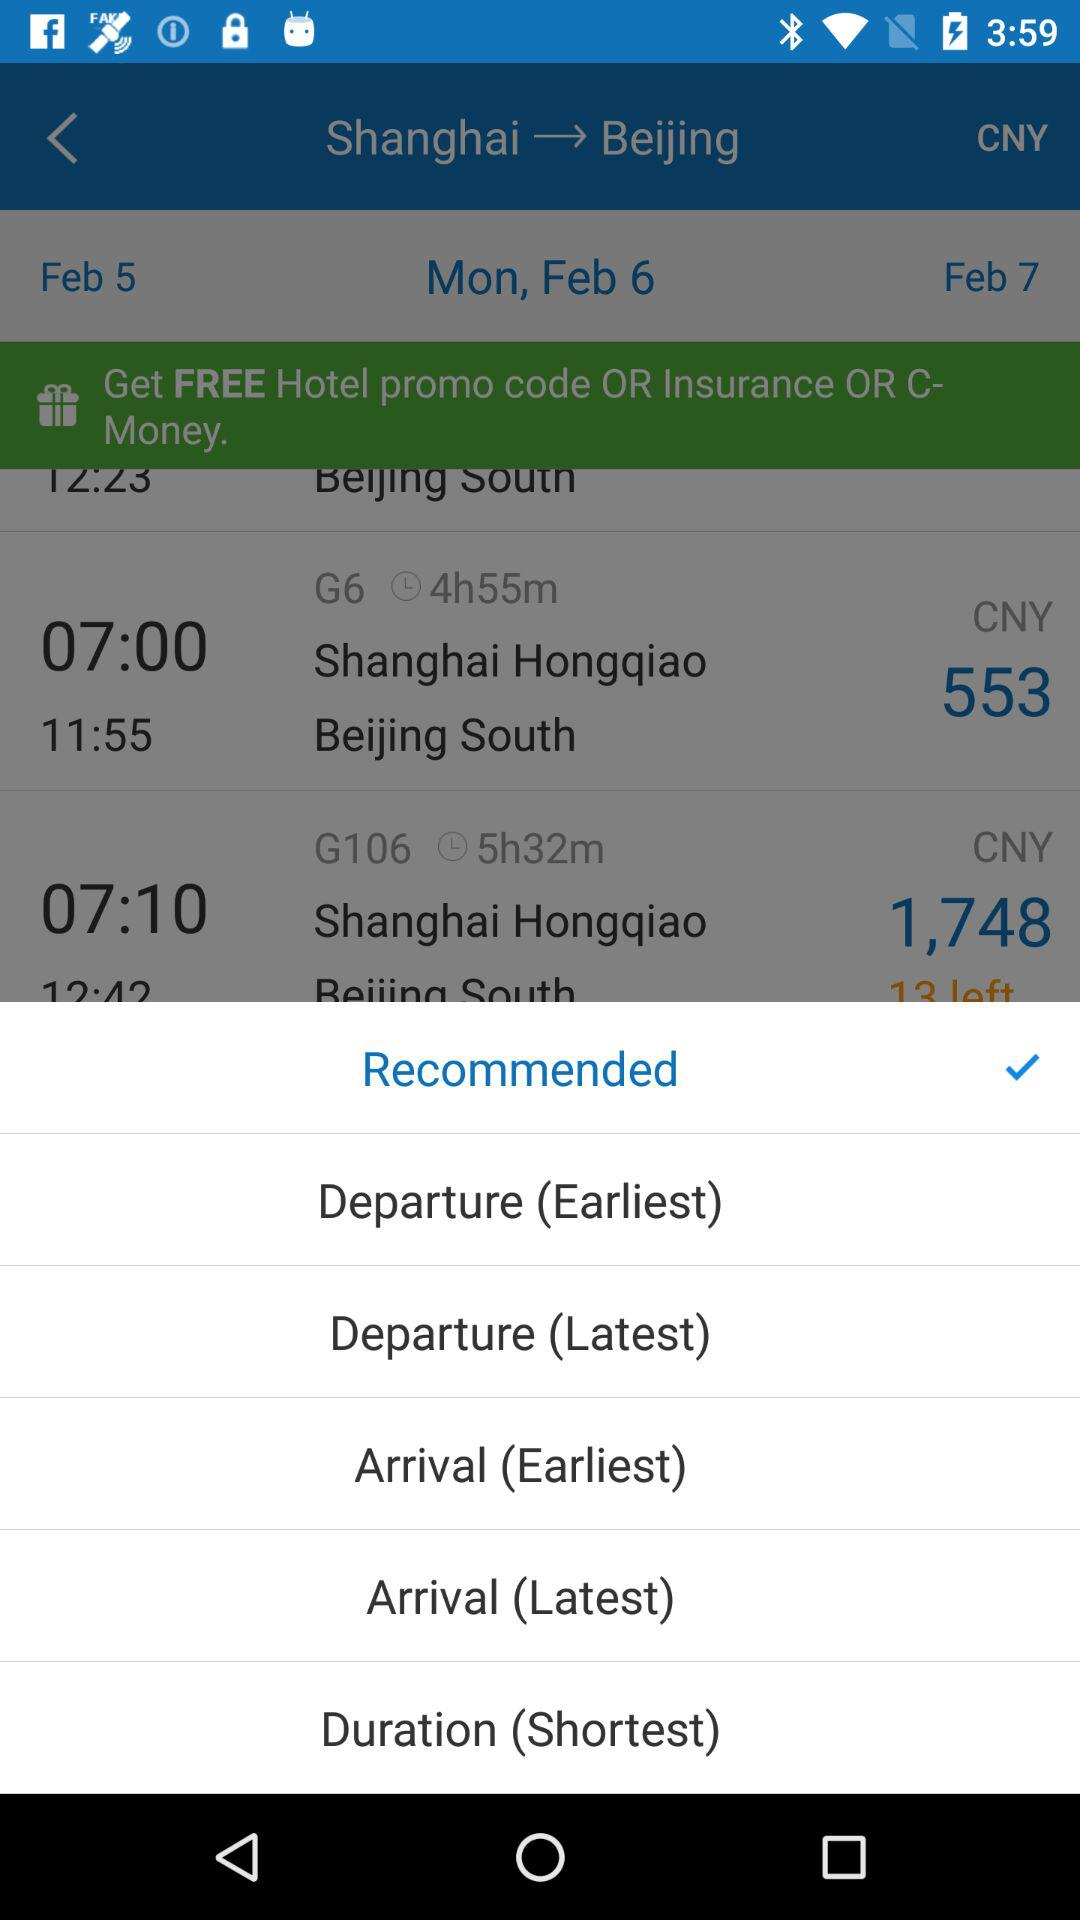Which option is selected? The selected option is "Recommended". 